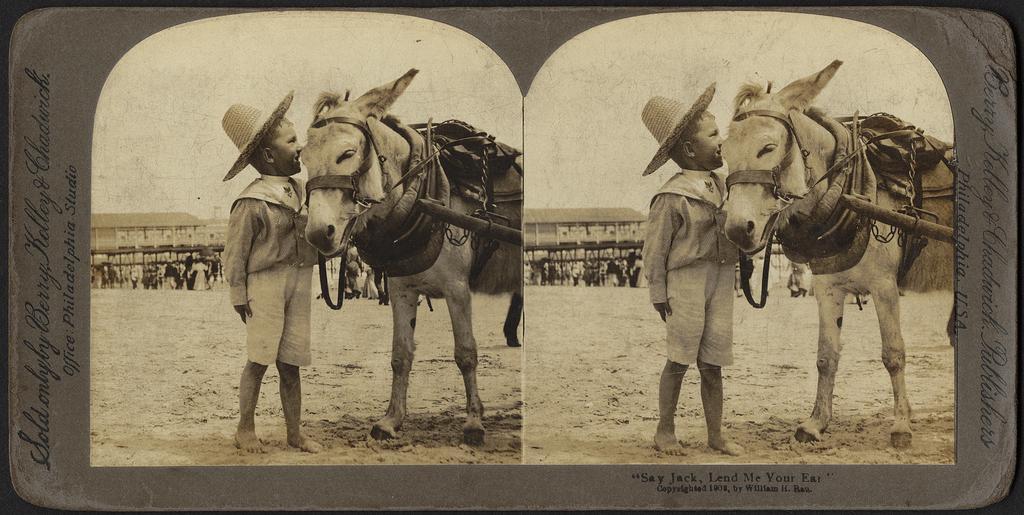How would you summarize this image in a sentence or two? This is a black and white image. In this image we can see collage pictures of person and horse on the sand. 